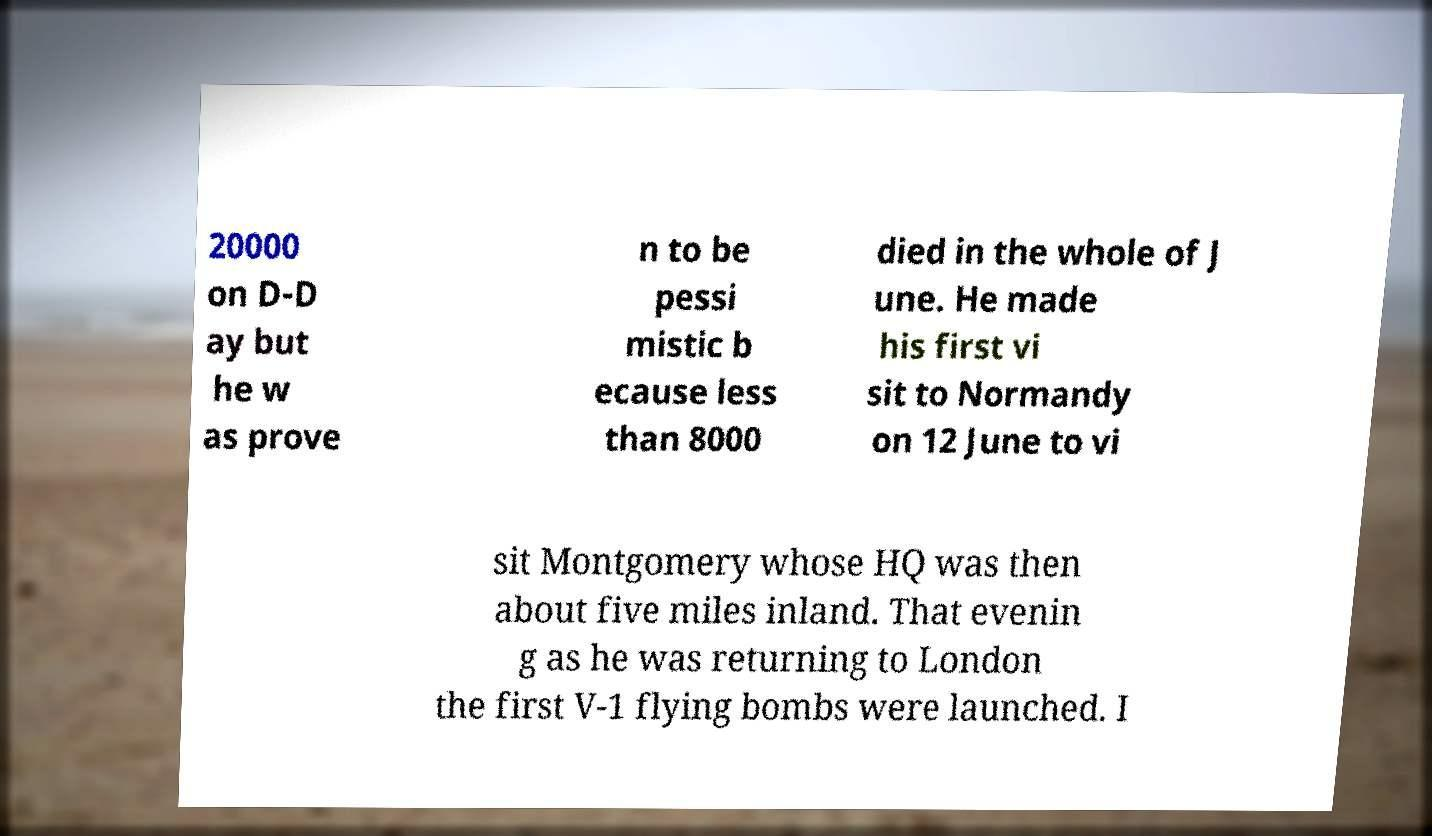Please read and relay the text visible in this image. What does it say? 20000 on D-D ay but he w as prove n to be pessi mistic b ecause less than 8000 died in the whole of J une. He made his first vi sit to Normandy on 12 June to vi sit Montgomery whose HQ was then about five miles inland. That evenin g as he was returning to London the first V-1 flying bombs were launched. I 